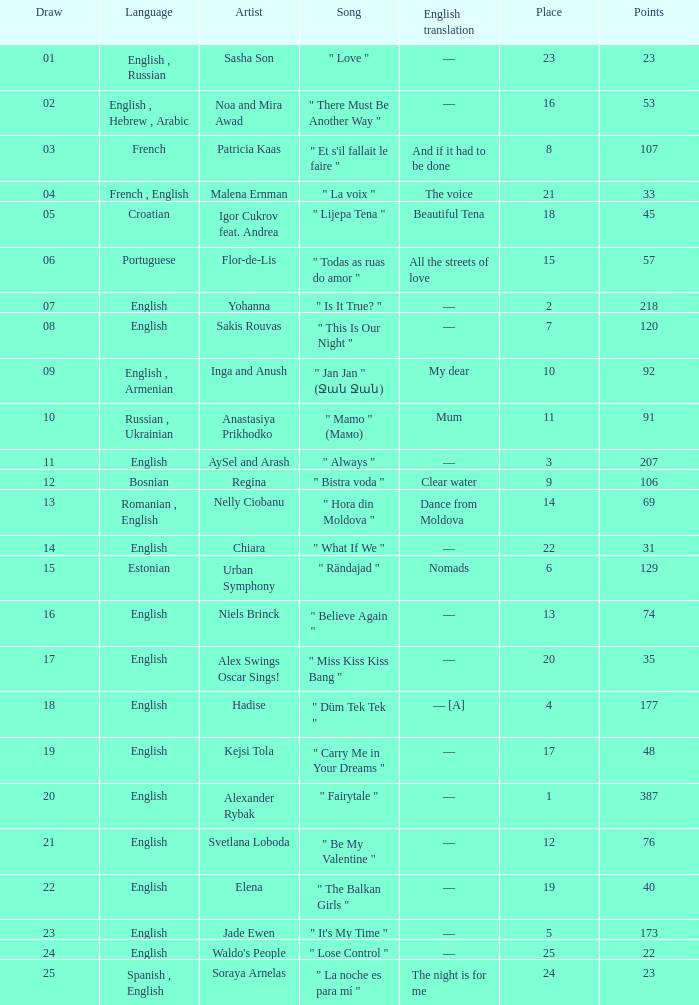What melody was in french? " Et s'il fallait le faire ". 